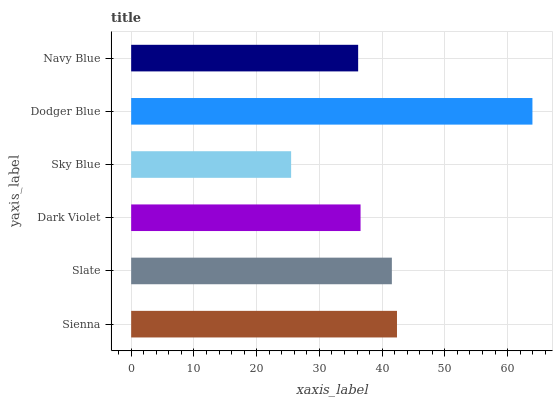Is Sky Blue the minimum?
Answer yes or no. Yes. Is Dodger Blue the maximum?
Answer yes or no. Yes. Is Slate the minimum?
Answer yes or no. No. Is Slate the maximum?
Answer yes or no. No. Is Sienna greater than Slate?
Answer yes or no. Yes. Is Slate less than Sienna?
Answer yes or no. Yes. Is Slate greater than Sienna?
Answer yes or no. No. Is Sienna less than Slate?
Answer yes or no. No. Is Slate the high median?
Answer yes or no. Yes. Is Dark Violet the low median?
Answer yes or no. Yes. Is Dodger Blue the high median?
Answer yes or no. No. Is Sky Blue the low median?
Answer yes or no. No. 